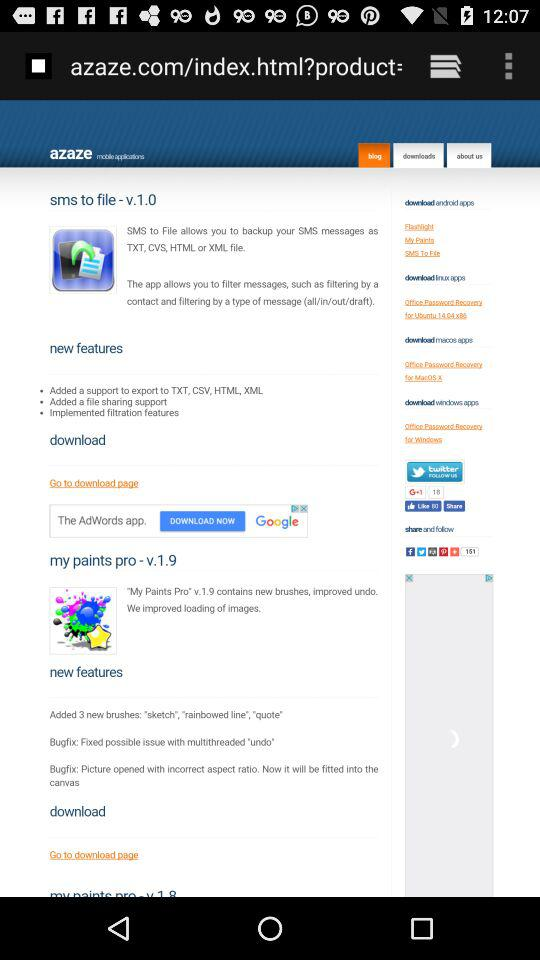What is the name of the application? The names of the applications are "sms to file" and "my paints pro". 